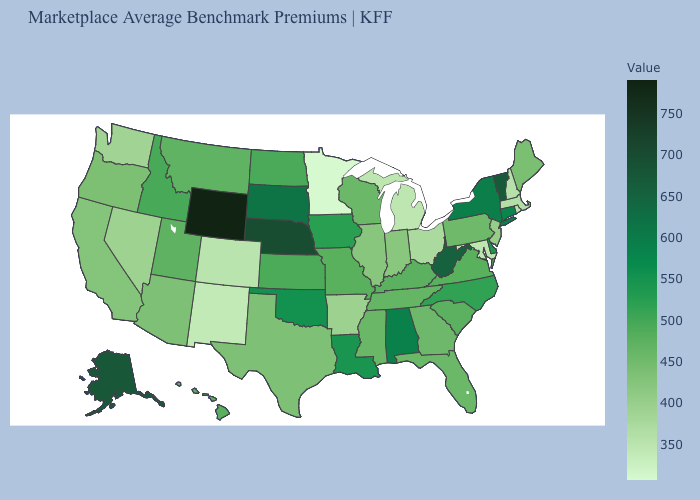Among the states that border Nebraska , does Colorado have the lowest value?
Short answer required. Yes. Among the states that border Mississippi , which have the highest value?
Write a very short answer. Alabama. Does the map have missing data?
Concise answer only. No. Does Rhode Island have the lowest value in the Northeast?
Write a very short answer. Yes. Is the legend a continuous bar?
Keep it brief. Yes. Among the states that border Arkansas , which have the highest value?
Write a very short answer. Oklahoma. Which states hav the highest value in the West?
Keep it brief. Wyoming. 